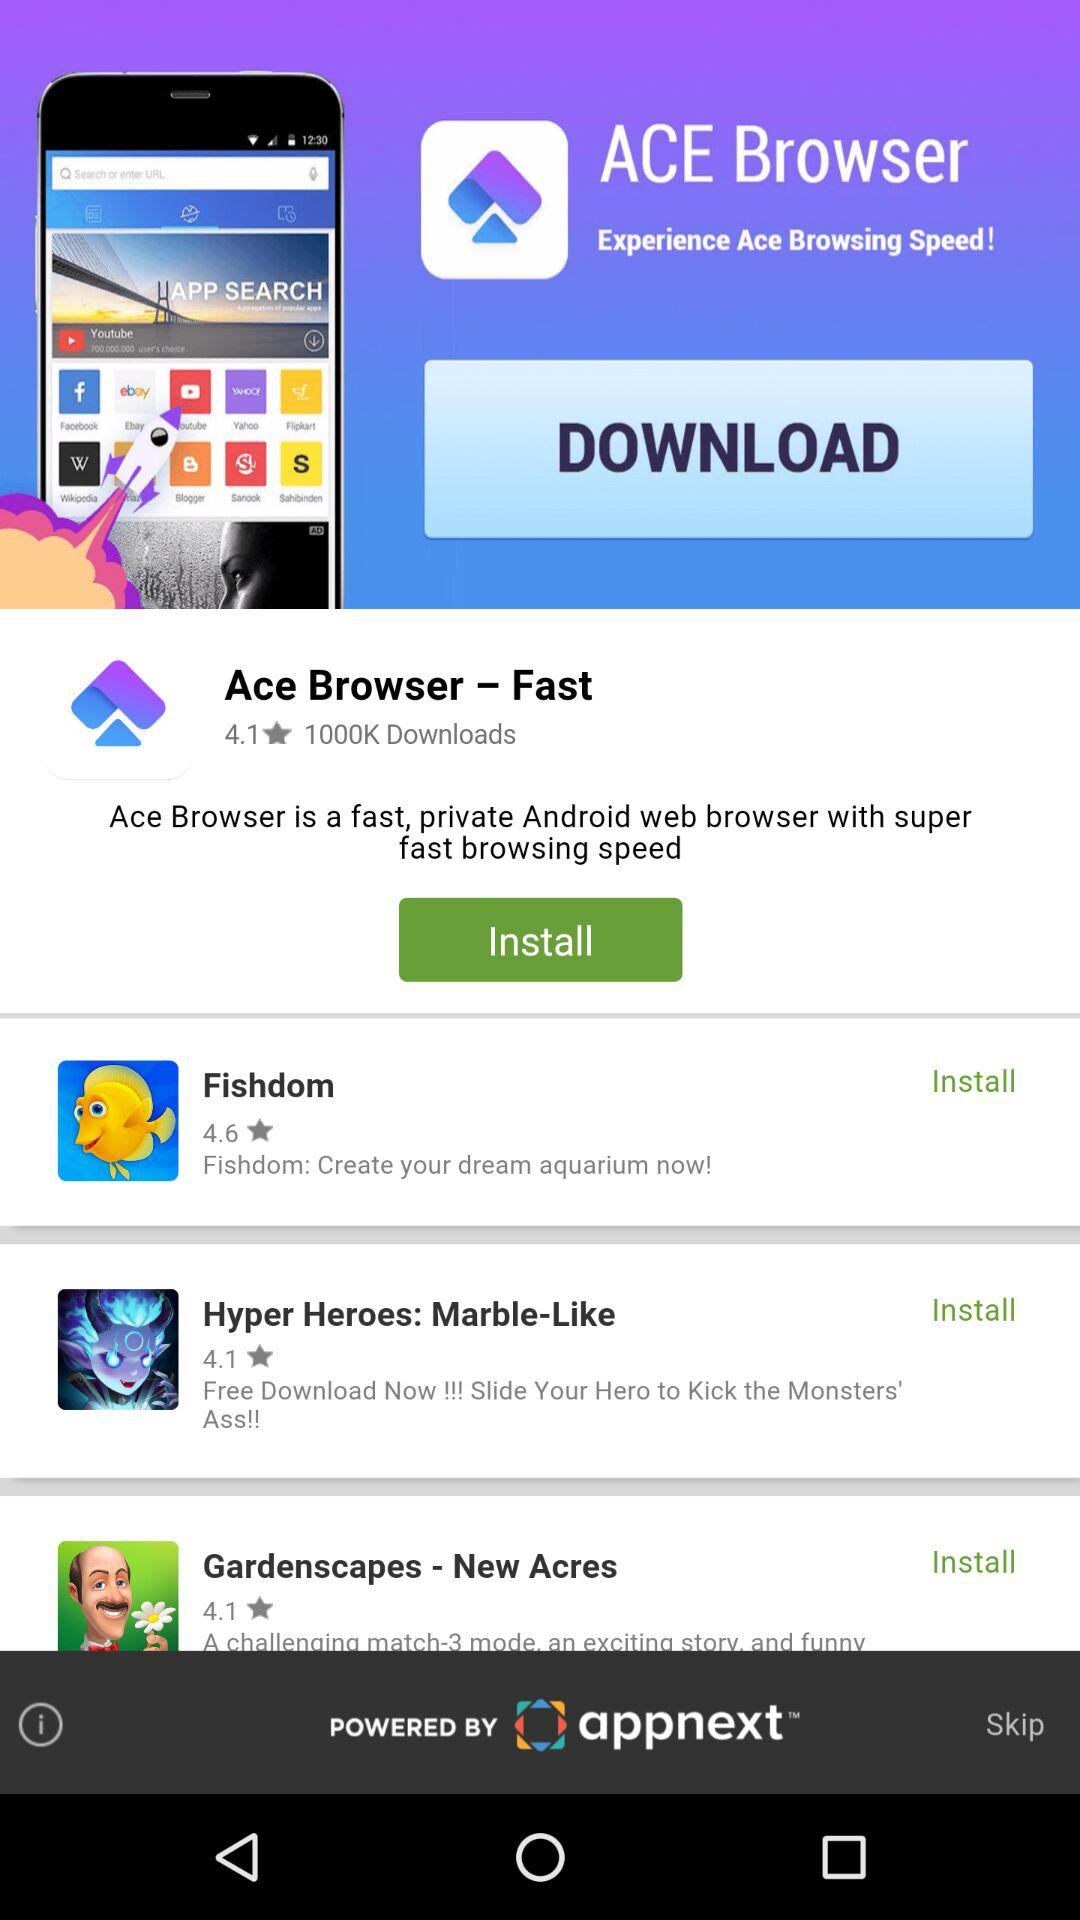How many downloads are there for "Ace Browser - Fast"? There are 1000K downloads for "Ace Browser - Fast". 